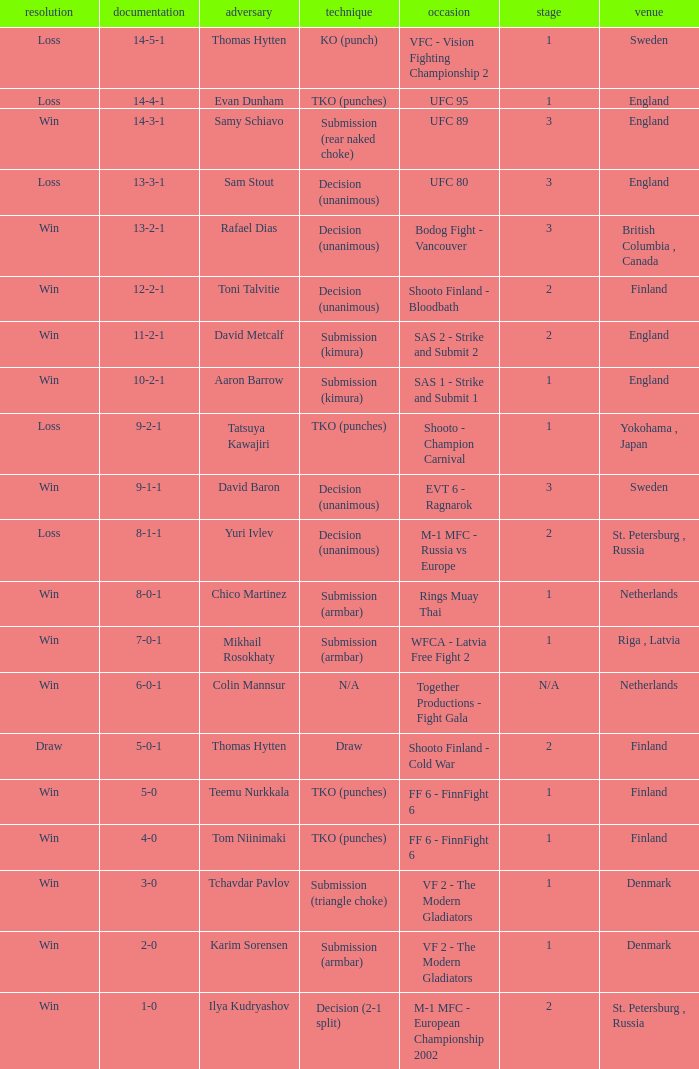Who was the opponent with a record of 14-4-1 and has a round of 1? Evan Dunham. 